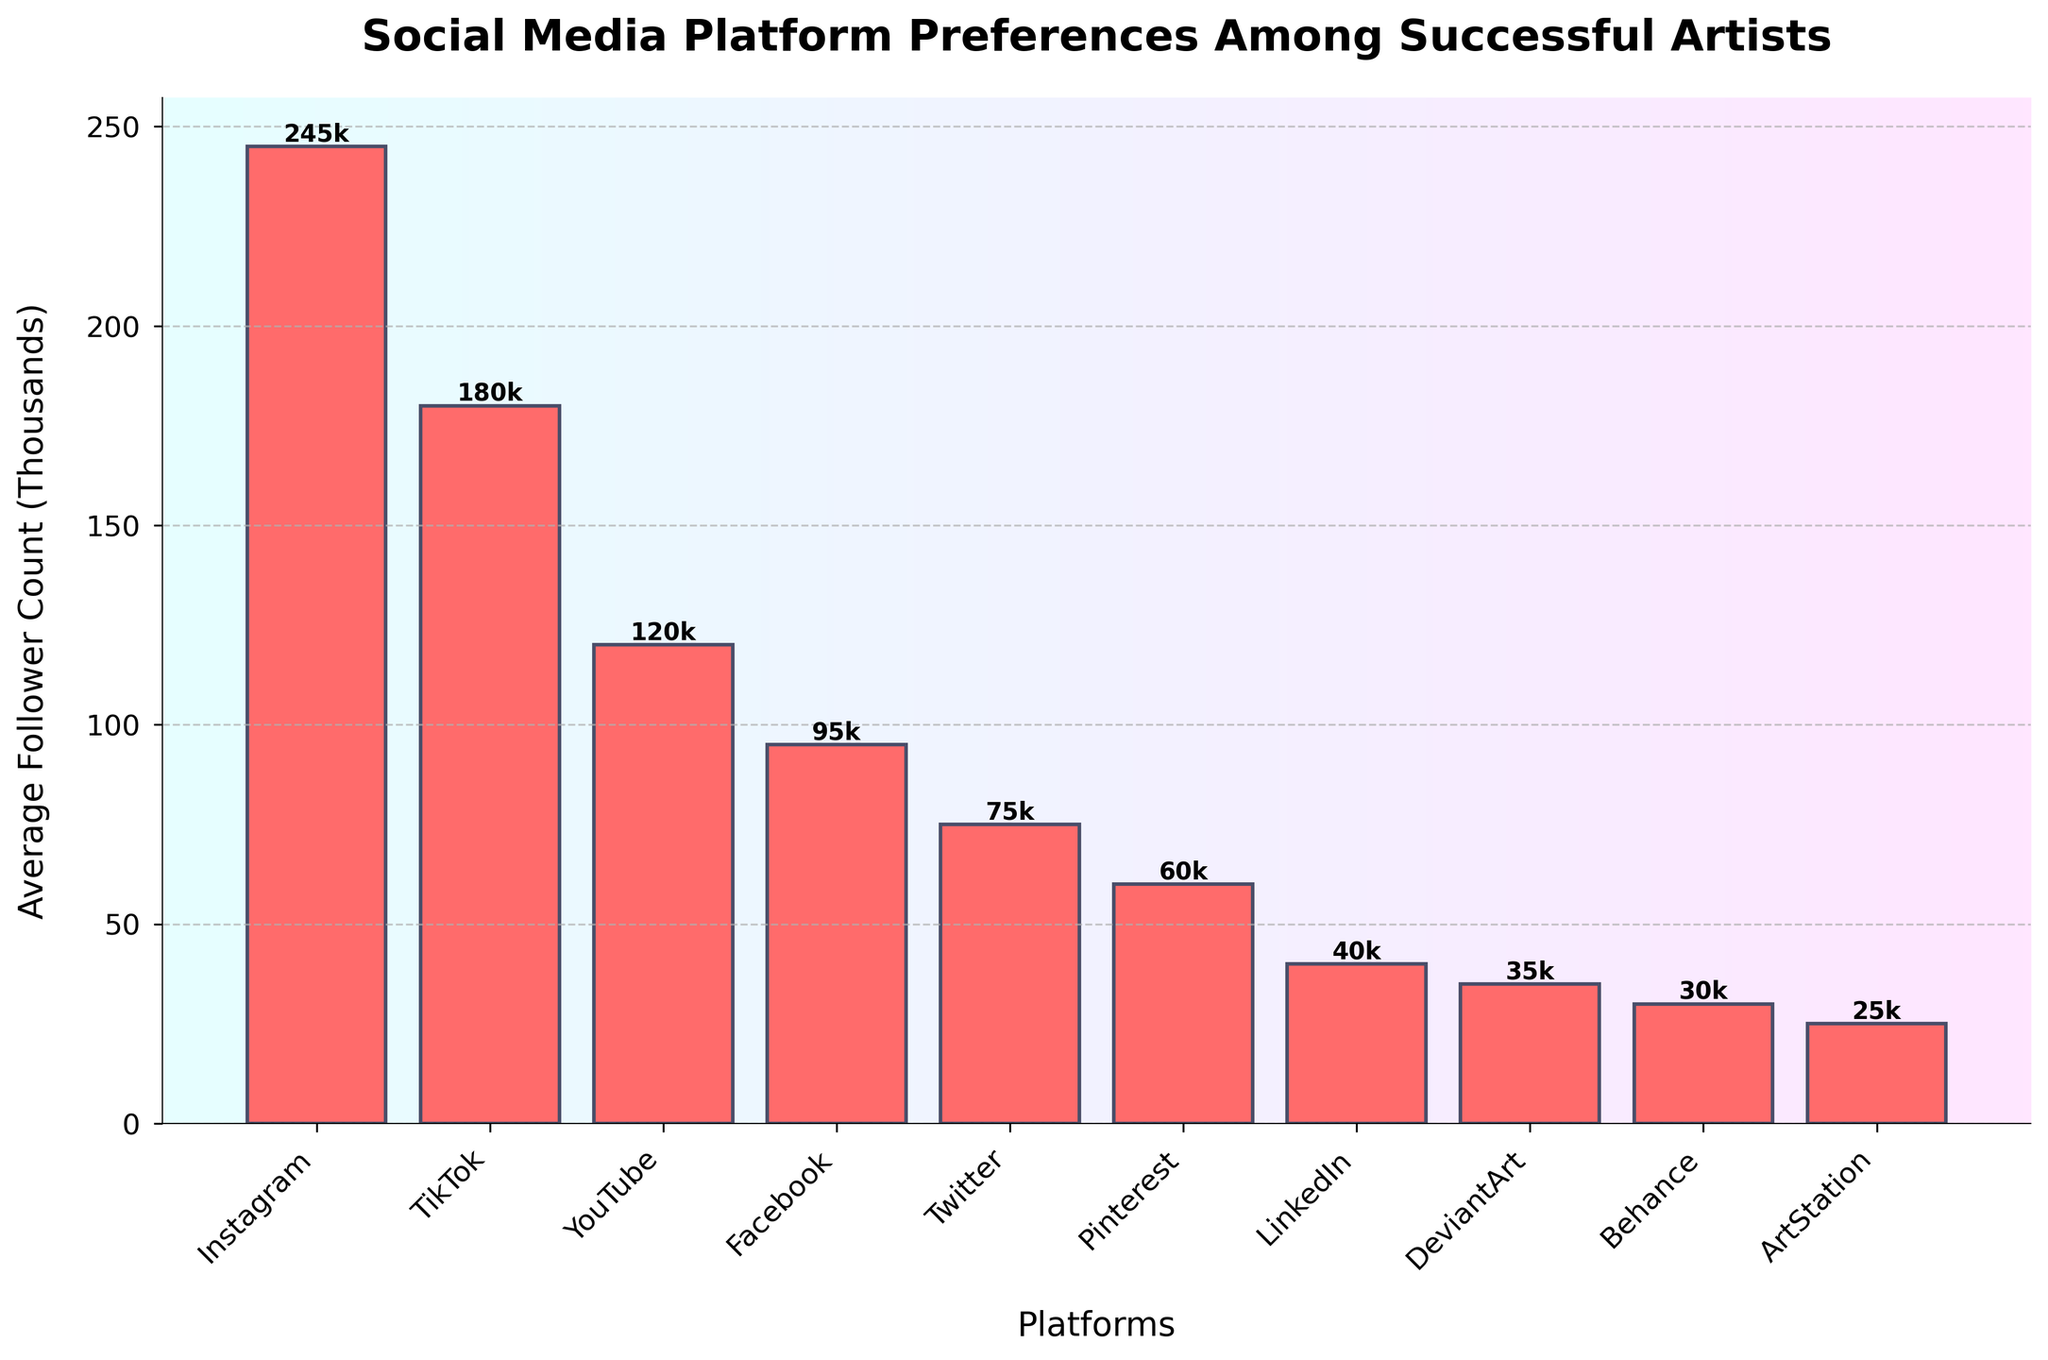Which platform has the highest average follower count? Look at the bars and find the tallest one, which represents Instagram with 245,000 followers (245k in the figure).
Answer: Instagram Which platform has the lowest average follower count? Identify the shortest bar that represents ArtStation with 25,000 followers (25k in the figure).
Answer: ArtStation What is the difference in average follower count between Instagram and TikTok? Find the heights of the bars for Instagram (245k) and TikTok (180k) and subtract the latter from the former: 245k - 180k = 65k.
Answer: 65k Which two platforms combined have an average follower count of 150,000? Add the heights of the bars until you find a combination that sums to 150k. Facebook (95k) and Twitter (75k) together equal 170k, the best fit after LinkedIn and DeviantArt (39k + 35k = 74k).
Answer: None exactly Which platforms have an average follower count greater than 100,000? Identify the bars taller than 100k. These are Instagram, TikTok, and YouTube.
Answer: Instagram, TikTok, YouTube Which platform has less than half the average follower count of Instagram? Calculate half of Instagram’s followers (245k / 2 = 122.5k) and find platforms with less. These include Pinterest, LinkedIn, DeviantArt, Behance, and ArtStation.
Answer: Pinterest, LinkedIn, DeviantArt, Behance, ArtStation Is the average follower count of Facebook closer to that of Twitter or YouTube? Compare the heights of Facebook (95k) against Twitter (75k) and YouTube (120k), and see which has the smallest difference: Facebook is 25k away from YouTube and 20k from Twitter.
Answer: Twitter What’s the total average follower count for the platforms with more than 50,000 followers? Sum the heights of bars representing platforms with more than 50k followers: Instagram (245k), TikTok (180k), YouTube (120k), Facebook (95k), Twitter (75k), Pinterest (60k). Total is 775k.
Answer: 775k What is the ratio of the average follower count between Instagram and Facebook? Ratio is calculated by dividing Instagram’s followers (245k) by Facebook’s (95k): 245k / 95k = 2.58.
Answer: 2.58 Which platforms have an average follower count between 50,000 and 100,000? Identify the bars whose heights fall within this range. These platforms are Facebook, Twitter, and Pinterest.
Answer: Facebook, Twitter, Pinterest 